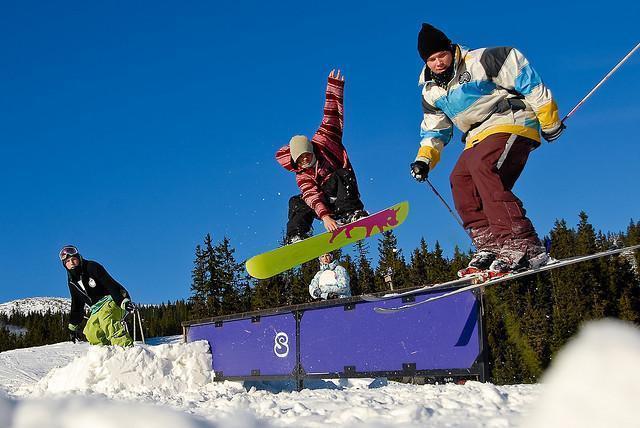What is the black hat the man is wearing called?
Select the accurate answer and provide explanation: 'Answer: answer
Rationale: rationale.'
Options: Top hat, derby, beanie, fedora. Answer: beanie.
Rationale: A top hat would be used with a dressier outfit as would a fedora and a derby. 